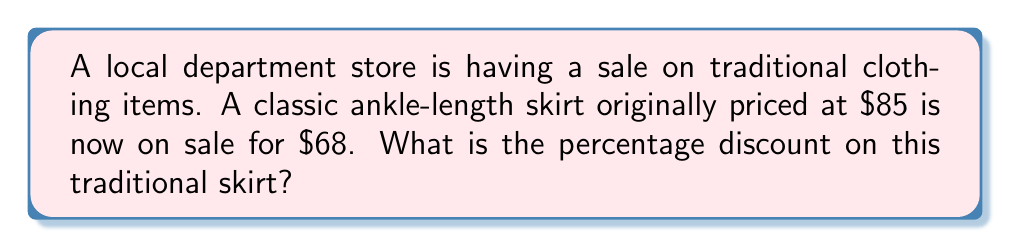Solve this math problem. To calculate the percentage discount, we need to follow these steps:

1. Calculate the amount of discount:
   Original price - Sale price = Discount amount
   $85 - $68 = $17

2. Set up the percentage discount formula:
   Percentage discount = $\frac{\text{Discount amount}}{\text{Original price}} \times 100\%$

3. Plug in the values:
   Percentage discount = $\frac{17}{85} \times 100\%$

4. Perform the division:
   $\frac{17}{85} = 0.2$

5. Multiply by 100% to get the percentage:
   $0.2 \times 100\% = 20\%$

Therefore, the percentage discount on the traditional skirt is 20%.
Answer: 20% 